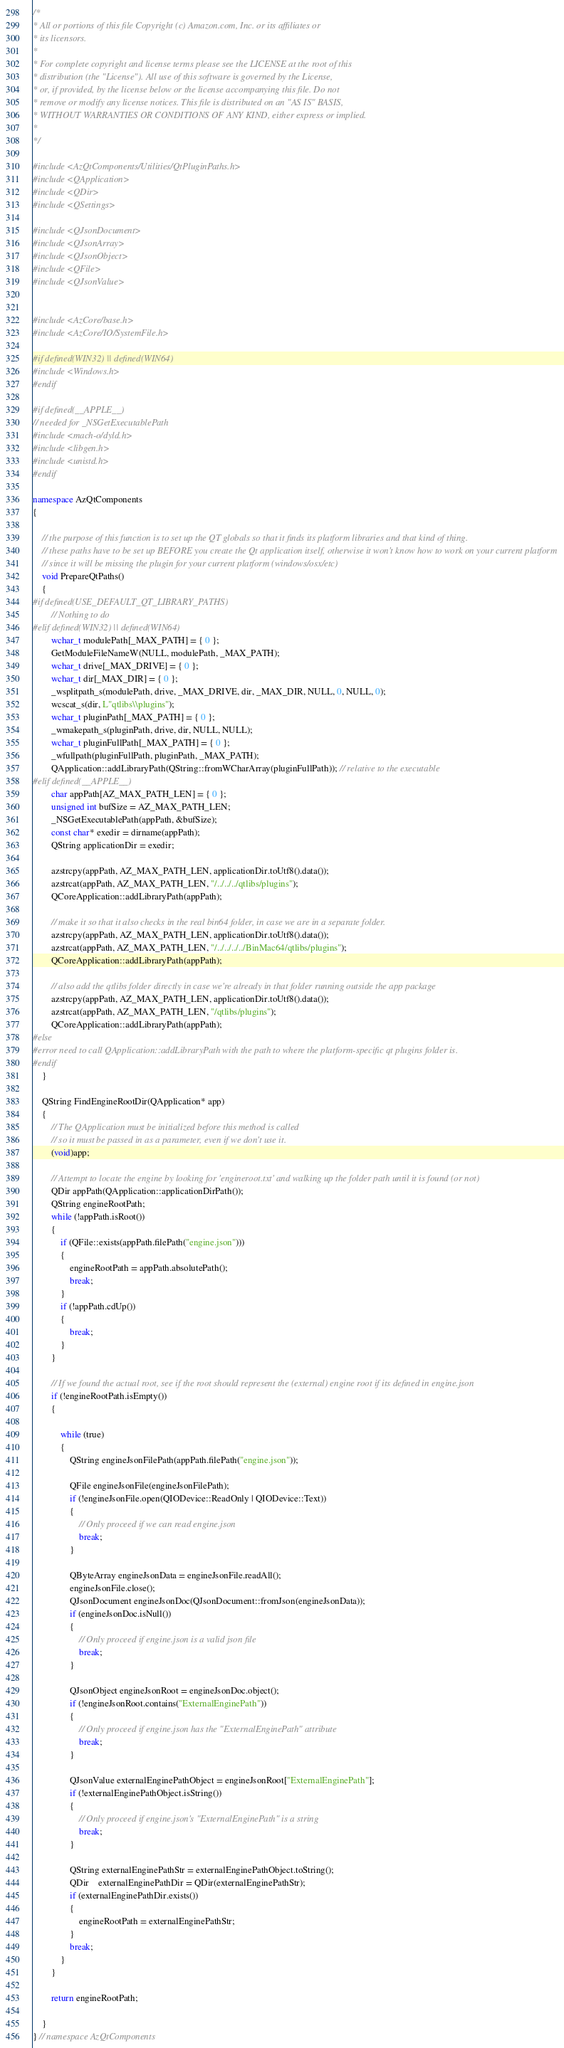<code> <loc_0><loc_0><loc_500><loc_500><_C++_>/*
* All or portions of this file Copyright (c) Amazon.com, Inc. or its affiliates or
* its licensors.
*
* For complete copyright and license terms please see the LICENSE at the root of this
* distribution (the "License"). All use of this software is governed by the License,
* or, if provided, by the license below or the license accompanying this file. Do not
* remove or modify any license notices. This file is distributed on an "AS IS" BASIS,
* WITHOUT WARRANTIES OR CONDITIONS OF ANY KIND, either express or implied.
*
*/

#include <AzQtComponents/Utilities/QtPluginPaths.h>
#include <QApplication>
#include <QDir>
#include <QSettings>

#include <QJsonDocument>
#include <QJsonArray>
#include <QJsonObject>
#include <QFile>
#include <QJsonValue>


#include <AzCore/base.h>
#include <AzCore/IO/SystemFile.h>

#if defined(WIN32) || defined(WIN64)
#include <Windows.h>
#endif

#if defined(__APPLE__)
// needed for _NSGetExecutablePath
#include <mach-o/dyld.h>
#include <libgen.h>
#include <unistd.h>
#endif

namespace AzQtComponents
{

    // the purpose of this function is to set up the QT globals so that it finds its platform libraries and that kind of thing.
    // these paths have to be set up BEFORE you create the Qt application itself, otherwise it won't know how to work on your current platform
    // since it will be missing the plugin for your current platform (windows/osx/etc)
    void PrepareQtPaths()
    {
#if defined(USE_DEFAULT_QT_LIBRARY_PATHS)
        // Nothing to do
#elif defined(WIN32) || defined(WIN64)
        wchar_t modulePath[_MAX_PATH] = { 0 };
        GetModuleFileNameW(NULL, modulePath, _MAX_PATH);
        wchar_t drive[_MAX_DRIVE] = { 0 };
        wchar_t dir[_MAX_DIR] = { 0 };
        _wsplitpath_s(modulePath, drive, _MAX_DRIVE, dir, _MAX_DIR, NULL, 0, NULL, 0);
        wcscat_s(dir, L"qtlibs\\plugins");
        wchar_t pluginPath[_MAX_PATH] = { 0 };
        _wmakepath_s(pluginPath, drive, dir, NULL, NULL);
        wchar_t pluginFullPath[_MAX_PATH] = { 0 };
        _wfullpath(pluginFullPath, pluginPath, _MAX_PATH);
        QApplication::addLibraryPath(QString::fromWCharArray(pluginFullPath)); // relative to the executable
#elif defined(__APPLE__)
        char appPath[AZ_MAX_PATH_LEN] = { 0 };
        unsigned int bufSize = AZ_MAX_PATH_LEN;
        _NSGetExecutablePath(appPath, &bufSize);
        const char* exedir = dirname(appPath);
        QString applicationDir = exedir;

        azstrcpy(appPath, AZ_MAX_PATH_LEN, applicationDir.toUtf8().data());
        azstrcat(appPath, AZ_MAX_PATH_LEN, "/../../../qtlibs/plugins");
        QCoreApplication::addLibraryPath(appPath);

        // make it so that it also checks in the real bin64 folder, in case we are in a separate folder.
        azstrcpy(appPath, AZ_MAX_PATH_LEN, applicationDir.toUtf8().data());
        azstrcat(appPath, AZ_MAX_PATH_LEN, "/../../../../BinMac64/qtlibs/plugins");
        QCoreApplication::addLibraryPath(appPath);

        // also add the qtlibs folder directly in case we're already in that folder running outside the app package
        azstrcpy(appPath, AZ_MAX_PATH_LEN, applicationDir.toUtf8().data());
        azstrcat(appPath, AZ_MAX_PATH_LEN, "/qtlibs/plugins");
        QCoreApplication::addLibraryPath(appPath);
#else
#error need to call QApplication::addLibraryPath with the path to where the platform-specific qt plugins folder is.
#endif
    }

    QString FindEngineRootDir(QApplication* app)
    {
        // The QApplication must be initialized before this method is called
        // so it must be passed in as a parameter, even if we don't use it.
        (void)app;

        // Attempt to locate the engine by looking for 'engineroot.txt' and walking up the folder path until it is found (or not)
        QDir appPath(QApplication::applicationDirPath());
        QString engineRootPath;
        while (!appPath.isRoot())
        {
            if (QFile::exists(appPath.filePath("engine.json")))
            {
                engineRootPath = appPath.absolutePath();
                break;
            }
            if (!appPath.cdUp())
            {
                break;
            }
        }

        // If we found the actual root, see if the root should represent the (external) engine root if its defined in engine.json 
        if (!engineRootPath.isEmpty())
        {

            while (true)
            {
                QString engineJsonFilePath(appPath.filePath("engine.json"));

                QFile engineJsonFile(engineJsonFilePath);
                if (!engineJsonFile.open(QIODevice::ReadOnly | QIODevice::Text))
                {
                    // Only proceed if we can read engine.json
                    break;
                }

                QByteArray engineJsonData = engineJsonFile.readAll();
                engineJsonFile.close();
                QJsonDocument engineJsonDoc(QJsonDocument::fromJson(engineJsonData));
                if (engineJsonDoc.isNull())
                {
                    // Only proceed if engine.json is a valid json file
                    break;
                }

                QJsonObject engineJsonRoot = engineJsonDoc.object();
                if (!engineJsonRoot.contains("ExternalEnginePath"))
                {
                    // Only proceed if engine.json has the "ExternalEnginePath" attribute
                    break;
                }

                QJsonValue externalEnginePathObject = engineJsonRoot["ExternalEnginePath"];
                if (!externalEnginePathObject.isString())
                {
                    // Only proceed if engine.json's "ExternalEnginePath" is a string
                    break;
                }

                QString externalEnginePathStr = externalEnginePathObject.toString();
                QDir    externalEnginePathDir = QDir(externalEnginePathStr);
                if (externalEnginePathDir.exists())
                {
                    engineRootPath = externalEnginePathStr;
                }
                break;
            }
        }

        return engineRootPath;

    }
} // namespace AzQtComponents

</code> 